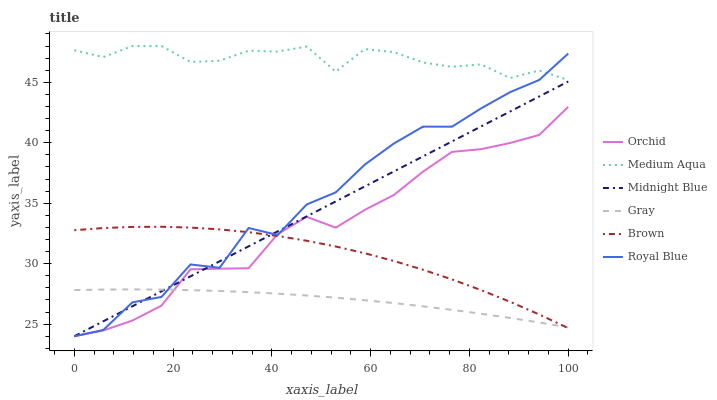Does Gray have the minimum area under the curve?
Answer yes or no. Yes. Does Medium Aqua have the maximum area under the curve?
Answer yes or no. Yes. Does Midnight Blue have the minimum area under the curve?
Answer yes or no. No. Does Midnight Blue have the maximum area under the curve?
Answer yes or no. No. Is Midnight Blue the smoothest?
Answer yes or no. Yes. Is Royal Blue the roughest?
Answer yes or no. Yes. Is Brown the smoothest?
Answer yes or no. No. Is Brown the roughest?
Answer yes or no. No. Does Midnight Blue have the lowest value?
Answer yes or no. Yes. Does Brown have the lowest value?
Answer yes or no. No. Does Medium Aqua have the highest value?
Answer yes or no. Yes. Does Midnight Blue have the highest value?
Answer yes or no. No. Is Midnight Blue less than Medium Aqua?
Answer yes or no. Yes. Is Medium Aqua greater than Midnight Blue?
Answer yes or no. Yes. Does Gray intersect Midnight Blue?
Answer yes or no. Yes. Is Gray less than Midnight Blue?
Answer yes or no. No. Is Gray greater than Midnight Blue?
Answer yes or no. No. Does Midnight Blue intersect Medium Aqua?
Answer yes or no. No. 